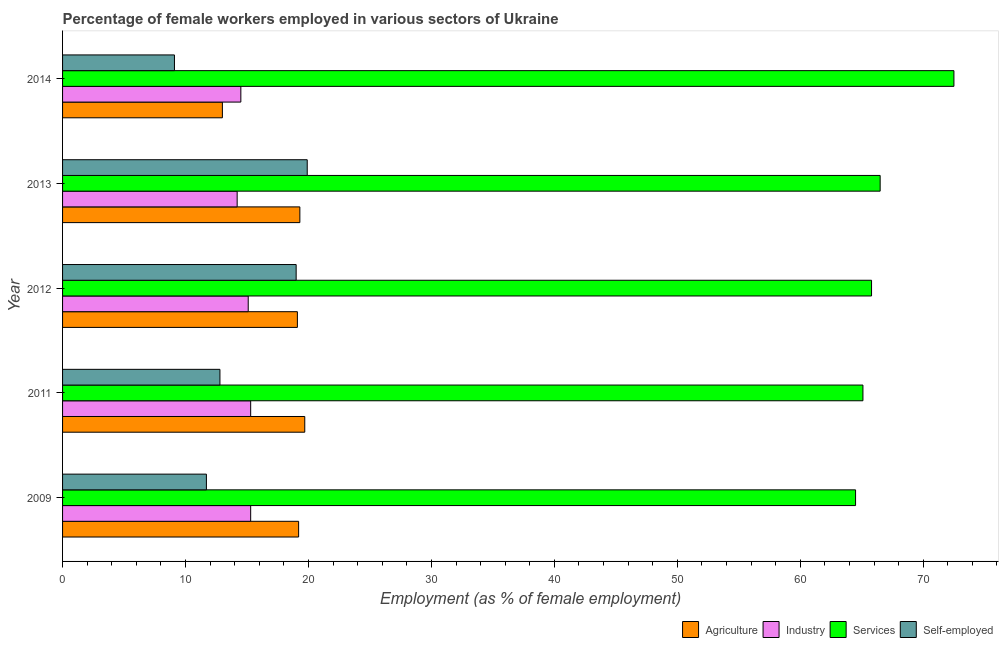Are the number of bars per tick equal to the number of legend labels?
Your response must be concise. Yes. What is the label of the 4th group of bars from the top?
Keep it short and to the point. 2011. What is the percentage of female workers in services in 2009?
Provide a succinct answer. 64.5. Across all years, what is the maximum percentage of female workers in services?
Ensure brevity in your answer.  72.5. Across all years, what is the minimum percentage of female workers in services?
Keep it short and to the point. 64.5. In which year was the percentage of female workers in industry minimum?
Offer a very short reply. 2013. What is the total percentage of self employed female workers in the graph?
Ensure brevity in your answer.  72.5. What is the difference between the percentage of self employed female workers in 2012 and that in 2014?
Provide a succinct answer. 9.9. What is the difference between the percentage of female workers in services in 2014 and the percentage of self employed female workers in 2009?
Make the answer very short. 60.8. What is the average percentage of female workers in agriculture per year?
Your answer should be compact. 18.06. What is the ratio of the percentage of self employed female workers in 2011 to that in 2013?
Give a very brief answer. 0.64. Is the difference between the percentage of self employed female workers in 2011 and 2012 greater than the difference between the percentage of female workers in industry in 2011 and 2012?
Keep it short and to the point. No. What is the difference between the highest and the second highest percentage of female workers in agriculture?
Make the answer very short. 0.4. In how many years, is the percentage of female workers in agriculture greater than the average percentage of female workers in agriculture taken over all years?
Your answer should be compact. 4. Is it the case that in every year, the sum of the percentage of self employed female workers and percentage of female workers in industry is greater than the sum of percentage of female workers in agriculture and percentage of female workers in services?
Provide a short and direct response. No. What does the 1st bar from the top in 2014 represents?
Offer a terse response. Self-employed. What does the 2nd bar from the bottom in 2011 represents?
Make the answer very short. Industry. Is it the case that in every year, the sum of the percentage of female workers in agriculture and percentage of female workers in industry is greater than the percentage of female workers in services?
Your response must be concise. No. How many bars are there?
Give a very brief answer. 20. How many years are there in the graph?
Keep it short and to the point. 5. Are the values on the major ticks of X-axis written in scientific E-notation?
Ensure brevity in your answer.  No. Where does the legend appear in the graph?
Your answer should be very brief. Bottom right. How are the legend labels stacked?
Offer a very short reply. Horizontal. What is the title of the graph?
Make the answer very short. Percentage of female workers employed in various sectors of Ukraine. Does "Switzerland" appear as one of the legend labels in the graph?
Keep it short and to the point. No. What is the label or title of the X-axis?
Offer a very short reply. Employment (as % of female employment). What is the Employment (as % of female employment) in Agriculture in 2009?
Your answer should be very brief. 19.2. What is the Employment (as % of female employment) of Industry in 2009?
Your answer should be compact. 15.3. What is the Employment (as % of female employment) of Services in 2009?
Make the answer very short. 64.5. What is the Employment (as % of female employment) in Self-employed in 2009?
Offer a very short reply. 11.7. What is the Employment (as % of female employment) of Agriculture in 2011?
Ensure brevity in your answer.  19.7. What is the Employment (as % of female employment) in Industry in 2011?
Keep it short and to the point. 15.3. What is the Employment (as % of female employment) in Services in 2011?
Your answer should be very brief. 65.1. What is the Employment (as % of female employment) in Self-employed in 2011?
Your response must be concise. 12.8. What is the Employment (as % of female employment) in Agriculture in 2012?
Provide a short and direct response. 19.1. What is the Employment (as % of female employment) in Industry in 2012?
Offer a terse response. 15.1. What is the Employment (as % of female employment) in Services in 2012?
Keep it short and to the point. 65.8. What is the Employment (as % of female employment) in Agriculture in 2013?
Provide a short and direct response. 19.3. What is the Employment (as % of female employment) of Industry in 2013?
Make the answer very short. 14.2. What is the Employment (as % of female employment) in Services in 2013?
Your response must be concise. 66.5. What is the Employment (as % of female employment) of Self-employed in 2013?
Offer a terse response. 19.9. What is the Employment (as % of female employment) in Services in 2014?
Give a very brief answer. 72.5. What is the Employment (as % of female employment) in Self-employed in 2014?
Give a very brief answer. 9.1. Across all years, what is the maximum Employment (as % of female employment) of Agriculture?
Give a very brief answer. 19.7. Across all years, what is the maximum Employment (as % of female employment) of Industry?
Your answer should be very brief. 15.3. Across all years, what is the maximum Employment (as % of female employment) of Services?
Offer a terse response. 72.5. Across all years, what is the maximum Employment (as % of female employment) of Self-employed?
Your answer should be compact. 19.9. Across all years, what is the minimum Employment (as % of female employment) of Agriculture?
Provide a succinct answer. 13. Across all years, what is the minimum Employment (as % of female employment) of Industry?
Your response must be concise. 14.2. Across all years, what is the minimum Employment (as % of female employment) in Services?
Make the answer very short. 64.5. Across all years, what is the minimum Employment (as % of female employment) in Self-employed?
Give a very brief answer. 9.1. What is the total Employment (as % of female employment) in Agriculture in the graph?
Provide a short and direct response. 90.3. What is the total Employment (as % of female employment) of Industry in the graph?
Provide a succinct answer. 74.4. What is the total Employment (as % of female employment) of Services in the graph?
Provide a short and direct response. 334.4. What is the total Employment (as % of female employment) in Self-employed in the graph?
Make the answer very short. 72.5. What is the difference between the Employment (as % of female employment) in Industry in 2009 and that in 2011?
Give a very brief answer. 0. What is the difference between the Employment (as % of female employment) in Agriculture in 2009 and that in 2012?
Provide a succinct answer. 0.1. What is the difference between the Employment (as % of female employment) of Self-employed in 2009 and that in 2012?
Make the answer very short. -7.3. What is the difference between the Employment (as % of female employment) in Agriculture in 2009 and that in 2013?
Keep it short and to the point. -0.1. What is the difference between the Employment (as % of female employment) of Industry in 2009 and that in 2013?
Your answer should be compact. 1.1. What is the difference between the Employment (as % of female employment) of Agriculture in 2009 and that in 2014?
Your response must be concise. 6.2. What is the difference between the Employment (as % of female employment) of Industry in 2009 and that in 2014?
Offer a very short reply. 0.8. What is the difference between the Employment (as % of female employment) of Services in 2009 and that in 2014?
Give a very brief answer. -8. What is the difference between the Employment (as % of female employment) in Self-employed in 2009 and that in 2014?
Offer a very short reply. 2.6. What is the difference between the Employment (as % of female employment) of Industry in 2011 and that in 2012?
Offer a very short reply. 0.2. What is the difference between the Employment (as % of female employment) of Services in 2011 and that in 2012?
Offer a terse response. -0.7. What is the difference between the Employment (as % of female employment) of Self-employed in 2011 and that in 2012?
Make the answer very short. -6.2. What is the difference between the Employment (as % of female employment) in Industry in 2011 and that in 2013?
Your response must be concise. 1.1. What is the difference between the Employment (as % of female employment) of Services in 2011 and that in 2013?
Keep it short and to the point. -1.4. What is the difference between the Employment (as % of female employment) in Self-employed in 2011 and that in 2013?
Provide a short and direct response. -7.1. What is the difference between the Employment (as % of female employment) of Agriculture in 2011 and that in 2014?
Offer a very short reply. 6.7. What is the difference between the Employment (as % of female employment) in Industry in 2011 and that in 2014?
Ensure brevity in your answer.  0.8. What is the difference between the Employment (as % of female employment) in Self-employed in 2011 and that in 2014?
Give a very brief answer. 3.7. What is the difference between the Employment (as % of female employment) of Agriculture in 2012 and that in 2013?
Keep it short and to the point. -0.2. What is the difference between the Employment (as % of female employment) in Industry in 2012 and that in 2013?
Ensure brevity in your answer.  0.9. What is the difference between the Employment (as % of female employment) of Services in 2012 and that in 2013?
Provide a succinct answer. -0.7. What is the difference between the Employment (as % of female employment) of Self-employed in 2012 and that in 2013?
Your response must be concise. -0.9. What is the difference between the Employment (as % of female employment) in Agriculture in 2012 and that in 2014?
Your answer should be compact. 6.1. What is the difference between the Employment (as % of female employment) in Industry in 2012 and that in 2014?
Provide a short and direct response. 0.6. What is the difference between the Employment (as % of female employment) of Self-employed in 2012 and that in 2014?
Offer a very short reply. 9.9. What is the difference between the Employment (as % of female employment) in Industry in 2013 and that in 2014?
Offer a terse response. -0.3. What is the difference between the Employment (as % of female employment) in Services in 2013 and that in 2014?
Offer a terse response. -6. What is the difference between the Employment (as % of female employment) of Self-employed in 2013 and that in 2014?
Give a very brief answer. 10.8. What is the difference between the Employment (as % of female employment) of Agriculture in 2009 and the Employment (as % of female employment) of Industry in 2011?
Make the answer very short. 3.9. What is the difference between the Employment (as % of female employment) of Agriculture in 2009 and the Employment (as % of female employment) of Services in 2011?
Provide a short and direct response. -45.9. What is the difference between the Employment (as % of female employment) of Agriculture in 2009 and the Employment (as % of female employment) of Self-employed in 2011?
Provide a short and direct response. 6.4. What is the difference between the Employment (as % of female employment) in Industry in 2009 and the Employment (as % of female employment) in Services in 2011?
Provide a short and direct response. -49.8. What is the difference between the Employment (as % of female employment) in Services in 2009 and the Employment (as % of female employment) in Self-employed in 2011?
Offer a very short reply. 51.7. What is the difference between the Employment (as % of female employment) in Agriculture in 2009 and the Employment (as % of female employment) in Services in 2012?
Your answer should be compact. -46.6. What is the difference between the Employment (as % of female employment) in Industry in 2009 and the Employment (as % of female employment) in Services in 2012?
Provide a short and direct response. -50.5. What is the difference between the Employment (as % of female employment) in Industry in 2009 and the Employment (as % of female employment) in Self-employed in 2012?
Offer a very short reply. -3.7. What is the difference between the Employment (as % of female employment) of Services in 2009 and the Employment (as % of female employment) of Self-employed in 2012?
Keep it short and to the point. 45.5. What is the difference between the Employment (as % of female employment) of Agriculture in 2009 and the Employment (as % of female employment) of Services in 2013?
Keep it short and to the point. -47.3. What is the difference between the Employment (as % of female employment) in Industry in 2009 and the Employment (as % of female employment) in Services in 2013?
Provide a short and direct response. -51.2. What is the difference between the Employment (as % of female employment) of Services in 2009 and the Employment (as % of female employment) of Self-employed in 2013?
Provide a short and direct response. 44.6. What is the difference between the Employment (as % of female employment) in Agriculture in 2009 and the Employment (as % of female employment) in Industry in 2014?
Provide a short and direct response. 4.7. What is the difference between the Employment (as % of female employment) in Agriculture in 2009 and the Employment (as % of female employment) in Services in 2014?
Make the answer very short. -53.3. What is the difference between the Employment (as % of female employment) of Industry in 2009 and the Employment (as % of female employment) of Services in 2014?
Make the answer very short. -57.2. What is the difference between the Employment (as % of female employment) of Industry in 2009 and the Employment (as % of female employment) of Self-employed in 2014?
Make the answer very short. 6.2. What is the difference between the Employment (as % of female employment) in Services in 2009 and the Employment (as % of female employment) in Self-employed in 2014?
Make the answer very short. 55.4. What is the difference between the Employment (as % of female employment) in Agriculture in 2011 and the Employment (as % of female employment) in Services in 2012?
Offer a very short reply. -46.1. What is the difference between the Employment (as % of female employment) of Agriculture in 2011 and the Employment (as % of female employment) of Self-employed in 2012?
Provide a short and direct response. 0.7. What is the difference between the Employment (as % of female employment) in Industry in 2011 and the Employment (as % of female employment) in Services in 2012?
Ensure brevity in your answer.  -50.5. What is the difference between the Employment (as % of female employment) of Industry in 2011 and the Employment (as % of female employment) of Self-employed in 2012?
Provide a short and direct response. -3.7. What is the difference between the Employment (as % of female employment) in Services in 2011 and the Employment (as % of female employment) in Self-employed in 2012?
Offer a very short reply. 46.1. What is the difference between the Employment (as % of female employment) of Agriculture in 2011 and the Employment (as % of female employment) of Services in 2013?
Offer a terse response. -46.8. What is the difference between the Employment (as % of female employment) of Agriculture in 2011 and the Employment (as % of female employment) of Self-employed in 2013?
Your answer should be compact. -0.2. What is the difference between the Employment (as % of female employment) of Industry in 2011 and the Employment (as % of female employment) of Services in 2013?
Give a very brief answer. -51.2. What is the difference between the Employment (as % of female employment) of Services in 2011 and the Employment (as % of female employment) of Self-employed in 2013?
Ensure brevity in your answer.  45.2. What is the difference between the Employment (as % of female employment) in Agriculture in 2011 and the Employment (as % of female employment) in Industry in 2014?
Ensure brevity in your answer.  5.2. What is the difference between the Employment (as % of female employment) of Agriculture in 2011 and the Employment (as % of female employment) of Services in 2014?
Provide a short and direct response. -52.8. What is the difference between the Employment (as % of female employment) in Agriculture in 2011 and the Employment (as % of female employment) in Self-employed in 2014?
Offer a terse response. 10.6. What is the difference between the Employment (as % of female employment) of Industry in 2011 and the Employment (as % of female employment) of Services in 2014?
Your answer should be compact. -57.2. What is the difference between the Employment (as % of female employment) of Agriculture in 2012 and the Employment (as % of female employment) of Services in 2013?
Your response must be concise. -47.4. What is the difference between the Employment (as % of female employment) of Agriculture in 2012 and the Employment (as % of female employment) of Self-employed in 2013?
Your answer should be very brief. -0.8. What is the difference between the Employment (as % of female employment) of Industry in 2012 and the Employment (as % of female employment) of Services in 2013?
Provide a short and direct response. -51.4. What is the difference between the Employment (as % of female employment) of Services in 2012 and the Employment (as % of female employment) of Self-employed in 2013?
Keep it short and to the point. 45.9. What is the difference between the Employment (as % of female employment) of Agriculture in 2012 and the Employment (as % of female employment) of Industry in 2014?
Provide a short and direct response. 4.6. What is the difference between the Employment (as % of female employment) of Agriculture in 2012 and the Employment (as % of female employment) of Services in 2014?
Provide a short and direct response. -53.4. What is the difference between the Employment (as % of female employment) in Industry in 2012 and the Employment (as % of female employment) in Services in 2014?
Make the answer very short. -57.4. What is the difference between the Employment (as % of female employment) of Services in 2012 and the Employment (as % of female employment) of Self-employed in 2014?
Offer a terse response. 56.7. What is the difference between the Employment (as % of female employment) of Agriculture in 2013 and the Employment (as % of female employment) of Services in 2014?
Offer a terse response. -53.2. What is the difference between the Employment (as % of female employment) of Agriculture in 2013 and the Employment (as % of female employment) of Self-employed in 2014?
Make the answer very short. 10.2. What is the difference between the Employment (as % of female employment) of Industry in 2013 and the Employment (as % of female employment) of Services in 2014?
Offer a terse response. -58.3. What is the difference between the Employment (as % of female employment) of Industry in 2013 and the Employment (as % of female employment) of Self-employed in 2014?
Give a very brief answer. 5.1. What is the difference between the Employment (as % of female employment) in Services in 2013 and the Employment (as % of female employment) in Self-employed in 2014?
Your answer should be compact. 57.4. What is the average Employment (as % of female employment) in Agriculture per year?
Offer a terse response. 18.06. What is the average Employment (as % of female employment) in Industry per year?
Make the answer very short. 14.88. What is the average Employment (as % of female employment) of Services per year?
Your response must be concise. 66.88. In the year 2009, what is the difference between the Employment (as % of female employment) in Agriculture and Employment (as % of female employment) in Industry?
Ensure brevity in your answer.  3.9. In the year 2009, what is the difference between the Employment (as % of female employment) of Agriculture and Employment (as % of female employment) of Services?
Your response must be concise. -45.3. In the year 2009, what is the difference between the Employment (as % of female employment) in Agriculture and Employment (as % of female employment) in Self-employed?
Ensure brevity in your answer.  7.5. In the year 2009, what is the difference between the Employment (as % of female employment) in Industry and Employment (as % of female employment) in Services?
Your answer should be compact. -49.2. In the year 2009, what is the difference between the Employment (as % of female employment) of Services and Employment (as % of female employment) of Self-employed?
Ensure brevity in your answer.  52.8. In the year 2011, what is the difference between the Employment (as % of female employment) in Agriculture and Employment (as % of female employment) in Services?
Provide a succinct answer. -45.4. In the year 2011, what is the difference between the Employment (as % of female employment) of Industry and Employment (as % of female employment) of Services?
Your answer should be compact. -49.8. In the year 2011, what is the difference between the Employment (as % of female employment) of Services and Employment (as % of female employment) of Self-employed?
Make the answer very short. 52.3. In the year 2012, what is the difference between the Employment (as % of female employment) of Agriculture and Employment (as % of female employment) of Services?
Give a very brief answer. -46.7. In the year 2012, what is the difference between the Employment (as % of female employment) of Agriculture and Employment (as % of female employment) of Self-employed?
Your response must be concise. 0.1. In the year 2012, what is the difference between the Employment (as % of female employment) of Industry and Employment (as % of female employment) of Services?
Offer a very short reply. -50.7. In the year 2012, what is the difference between the Employment (as % of female employment) in Industry and Employment (as % of female employment) in Self-employed?
Your answer should be compact. -3.9. In the year 2012, what is the difference between the Employment (as % of female employment) in Services and Employment (as % of female employment) in Self-employed?
Offer a terse response. 46.8. In the year 2013, what is the difference between the Employment (as % of female employment) of Agriculture and Employment (as % of female employment) of Industry?
Provide a succinct answer. 5.1. In the year 2013, what is the difference between the Employment (as % of female employment) of Agriculture and Employment (as % of female employment) of Services?
Your answer should be very brief. -47.2. In the year 2013, what is the difference between the Employment (as % of female employment) in Industry and Employment (as % of female employment) in Services?
Your response must be concise. -52.3. In the year 2013, what is the difference between the Employment (as % of female employment) in Industry and Employment (as % of female employment) in Self-employed?
Your answer should be very brief. -5.7. In the year 2013, what is the difference between the Employment (as % of female employment) in Services and Employment (as % of female employment) in Self-employed?
Make the answer very short. 46.6. In the year 2014, what is the difference between the Employment (as % of female employment) in Agriculture and Employment (as % of female employment) in Services?
Your answer should be compact. -59.5. In the year 2014, what is the difference between the Employment (as % of female employment) in Agriculture and Employment (as % of female employment) in Self-employed?
Your answer should be compact. 3.9. In the year 2014, what is the difference between the Employment (as % of female employment) of Industry and Employment (as % of female employment) of Services?
Keep it short and to the point. -58. In the year 2014, what is the difference between the Employment (as % of female employment) in Services and Employment (as % of female employment) in Self-employed?
Your answer should be compact. 63.4. What is the ratio of the Employment (as % of female employment) of Agriculture in 2009 to that in 2011?
Make the answer very short. 0.97. What is the ratio of the Employment (as % of female employment) of Services in 2009 to that in 2011?
Your response must be concise. 0.99. What is the ratio of the Employment (as % of female employment) in Self-employed in 2009 to that in 2011?
Your answer should be compact. 0.91. What is the ratio of the Employment (as % of female employment) in Industry in 2009 to that in 2012?
Provide a short and direct response. 1.01. What is the ratio of the Employment (as % of female employment) in Services in 2009 to that in 2012?
Offer a terse response. 0.98. What is the ratio of the Employment (as % of female employment) in Self-employed in 2009 to that in 2012?
Your answer should be very brief. 0.62. What is the ratio of the Employment (as % of female employment) of Industry in 2009 to that in 2013?
Give a very brief answer. 1.08. What is the ratio of the Employment (as % of female employment) of Services in 2009 to that in 2013?
Offer a terse response. 0.97. What is the ratio of the Employment (as % of female employment) in Self-employed in 2009 to that in 2013?
Offer a very short reply. 0.59. What is the ratio of the Employment (as % of female employment) of Agriculture in 2009 to that in 2014?
Offer a terse response. 1.48. What is the ratio of the Employment (as % of female employment) in Industry in 2009 to that in 2014?
Offer a very short reply. 1.06. What is the ratio of the Employment (as % of female employment) in Services in 2009 to that in 2014?
Keep it short and to the point. 0.89. What is the ratio of the Employment (as % of female employment) of Agriculture in 2011 to that in 2012?
Offer a very short reply. 1.03. What is the ratio of the Employment (as % of female employment) in Industry in 2011 to that in 2012?
Provide a short and direct response. 1.01. What is the ratio of the Employment (as % of female employment) in Services in 2011 to that in 2012?
Provide a short and direct response. 0.99. What is the ratio of the Employment (as % of female employment) in Self-employed in 2011 to that in 2012?
Provide a short and direct response. 0.67. What is the ratio of the Employment (as % of female employment) of Agriculture in 2011 to that in 2013?
Provide a succinct answer. 1.02. What is the ratio of the Employment (as % of female employment) of Industry in 2011 to that in 2013?
Your answer should be compact. 1.08. What is the ratio of the Employment (as % of female employment) in Services in 2011 to that in 2013?
Provide a short and direct response. 0.98. What is the ratio of the Employment (as % of female employment) in Self-employed in 2011 to that in 2013?
Your answer should be very brief. 0.64. What is the ratio of the Employment (as % of female employment) of Agriculture in 2011 to that in 2014?
Make the answer very short. 1.52. What is the ratio of the Employment (as % of female employment) of Industry in 2011 to that in 2014?
Ensure brevity in your answer.  1.06. What is the ratio of the Employment (as % of female employment) of Services in 2011 to that in 2014?
Keep it short and to the point. 0.9. What is the ratio of the Employment (as % of female employment) of Self-employed in 2011 to that in 2014?
Make the answer very short. 1.41. What is the ratio of the Employment (as % of female employment) of Agriculture in 2012 to that in 2013?
Offer a terse response. 0.99. What is the ratio of the Employment (as % of female employment) in Industry in 2012 to that in 2013?
Provide a short and direct response. 1.06. What is the ratio of the Employment (as % of female employment) in Self-employed in 2012 to that in 2013?
Offer a terse response. 0.95. What is the ratio of the Employment (as % of female employment) in Agriculture in 2012 to that in 2014?
Give a very brief answer. 1.47. What is the ratio of the Employment (as % of female employment) of Industry in 2012 to that in 2014?
Offer a very short reply. 1.04. What is the ratio of the Employment (as % of female employment) in Services in 2012 to that in 2014?
Make the answer very short. 0.91. What is the ratio of the Employment (as % of female employment) of Self-employed in 2012 to that in 2014?
Your response must be concise. 2.09. What is the ratio of the Employment (as % of female employment) in Agriculture in 2013 to that in 2014?
Keep it short and to the point. 1.48. What is the ratio of the Employment (as % of female employment) of Industry in 2013 to that in 2014?
Your answer should be very brief. 0.98. What is the ratio of the Employment (as % of female employment) in Services in 2013 to that in 2014?
Ensure brevity in your answer.  0.92. What is the ratio of the Employment (as % of female employment) in Self-employed in 2013 to that in 2014?
Offer a very short reply. 2.19. What is the difference between the highest and the second highest Employment (as % of female employment) in Services?
Your answer should be compact. 6. What is the difference between the highest and the second highest Employment (as % of female employment) in Self-employed?
Offer a terse response. 0.9. What is the difference between the highest and the lowest Employment (as % of female employment) of Agriculture?
Your answer should be very brief. 6.7. What is the difference between the highest and the lowest Employment (as % of female employment) of Industry?
Offer a terse response. 1.1. 